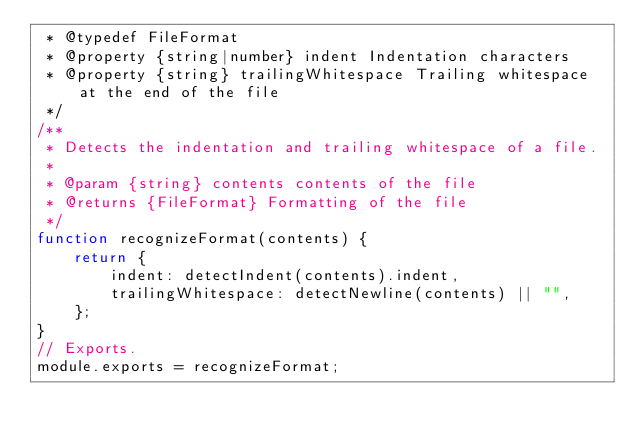Convert code to text. <code><loc_0><loc_0><loc_500><loc_500><_JavaScript_> * @typedef FileFormat
 * @property {string|number} indent Indentation characters
 * @property {string} trailingWhitespace Trailing whitespace at the end of the file
 */
/**
 * Detects the indentation and trailing whitespace of a file.
 *
 * @param {string} contents contents of the file
 * @returns {FileFormat} Formatting of the file
 */
function recognizeFormat(contents) {
    return {
        indent: detectIndent(contents).indent,
        trailingWhitespace: detectNewline(contents) || "",
    };
}
// Exports.
module.exports = recognizeFormat;
</code> 